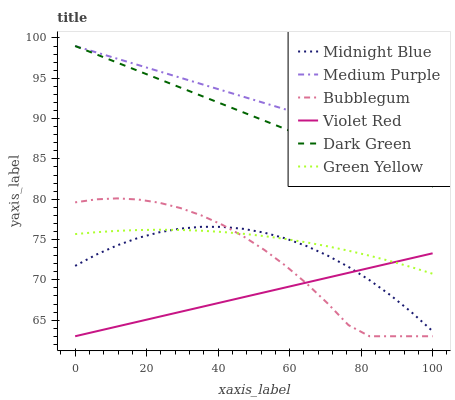Does Violet Red have the minimum area under the curve?
Answer yes or no. Yes. Does Medium Purple have the maximum area under the curve?
Answer yes or no. Yes. Does Midnight Blue have the minimum area under the curve?
Answer yes or no. No. Does Midnight Blue have the maximum area under the curve?
Answer yes or no. No. Is Medium Purple the smoothest?
Answer yes or no. Yes. Is Bubblegum the roughest?
Answer yes or no. Yes. Is Midnight Blue the smoothest?
Answer yes or no. No. Is Midnight Blue the roughest?
Answer yes or no. No. Does Violet Red have the lowest value?
Answer yes or no. Yes. Does Midnight Blue have the lowest value?
Answer yes or no. No. Does Dark Green have the highest value?
Answer yes or no. Yes. Does Midnight Blue have the highest value?
Answer yes or no. No. Is Violet Red less than Medium Purple?
Answer yes or no. Yes. Is Medium Purple greater than Violet Red?
Answer yes or no. Yes. Does Midnight Blue intersect Green Yellow?
Answer yes or no. Yes. Is Midnight Blue less than Green Yellow?
Answer yes or no. No. Is Midnight Blue greater than Green Yellow?
Answer yes or no. No. Does Violet Red intersect Medium Purple?
Answer yes or no. No. 